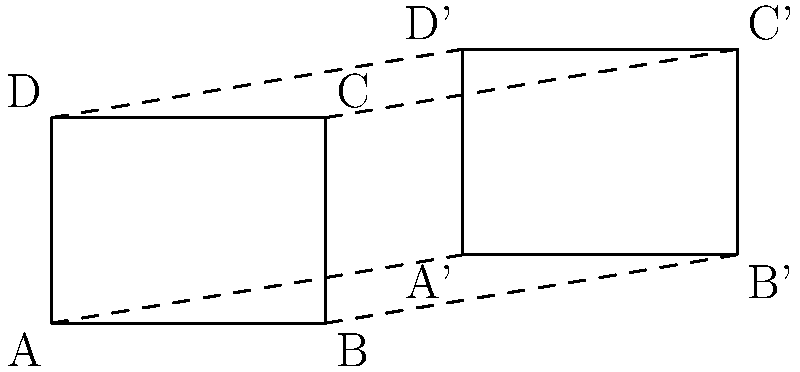Two rectangular search patterns for maritime patrols are shown above. Determine if these patterns are congruent and, if so, describe the transformation that maps one onto the other. To determine if the two rectangular search patterns are congruent and identify the transformation, we'll follow these steps:

1. Check if the rectangles have the same shape and size:
   - Rectangle ABCD: 4 units wide, 3 units tall
   - Rectangle A'B'C'D': 4 units wide, 3 units tall
   The rectangles have the same dimensions, so they are congruent.

2. Identify the transformation:
   a) Translation:
      - From A to A': 6 units right, 1 unit up
      - From B to B': 6 units right, 1 unit up
      - From C to C': 6 units right, 1 unit up
      - From D to D': 6 units right, 1 unit up

   b) The same translation vector $(6,1)$ applies to all vertices.

3. Verify the transformation:
   - Apply the translation $T(x,y) = (x+6, y+1)$ to all points of ABCD:
     A(0,0) → A'(6,1)
     B(4,0) → B'(10,1)
     C(4,3) → C'(10,4)
     D(0,3) → D'(6,4)

   This matches the coordinates of A'B'C'D'.

Therefore, the two search patterns are congruent, and the transformation that maps ABCD onto A'B'C'D' is a translation by the vector $(6,1)$.
Answer: Congruent; translation by vector $(6,1)$ 